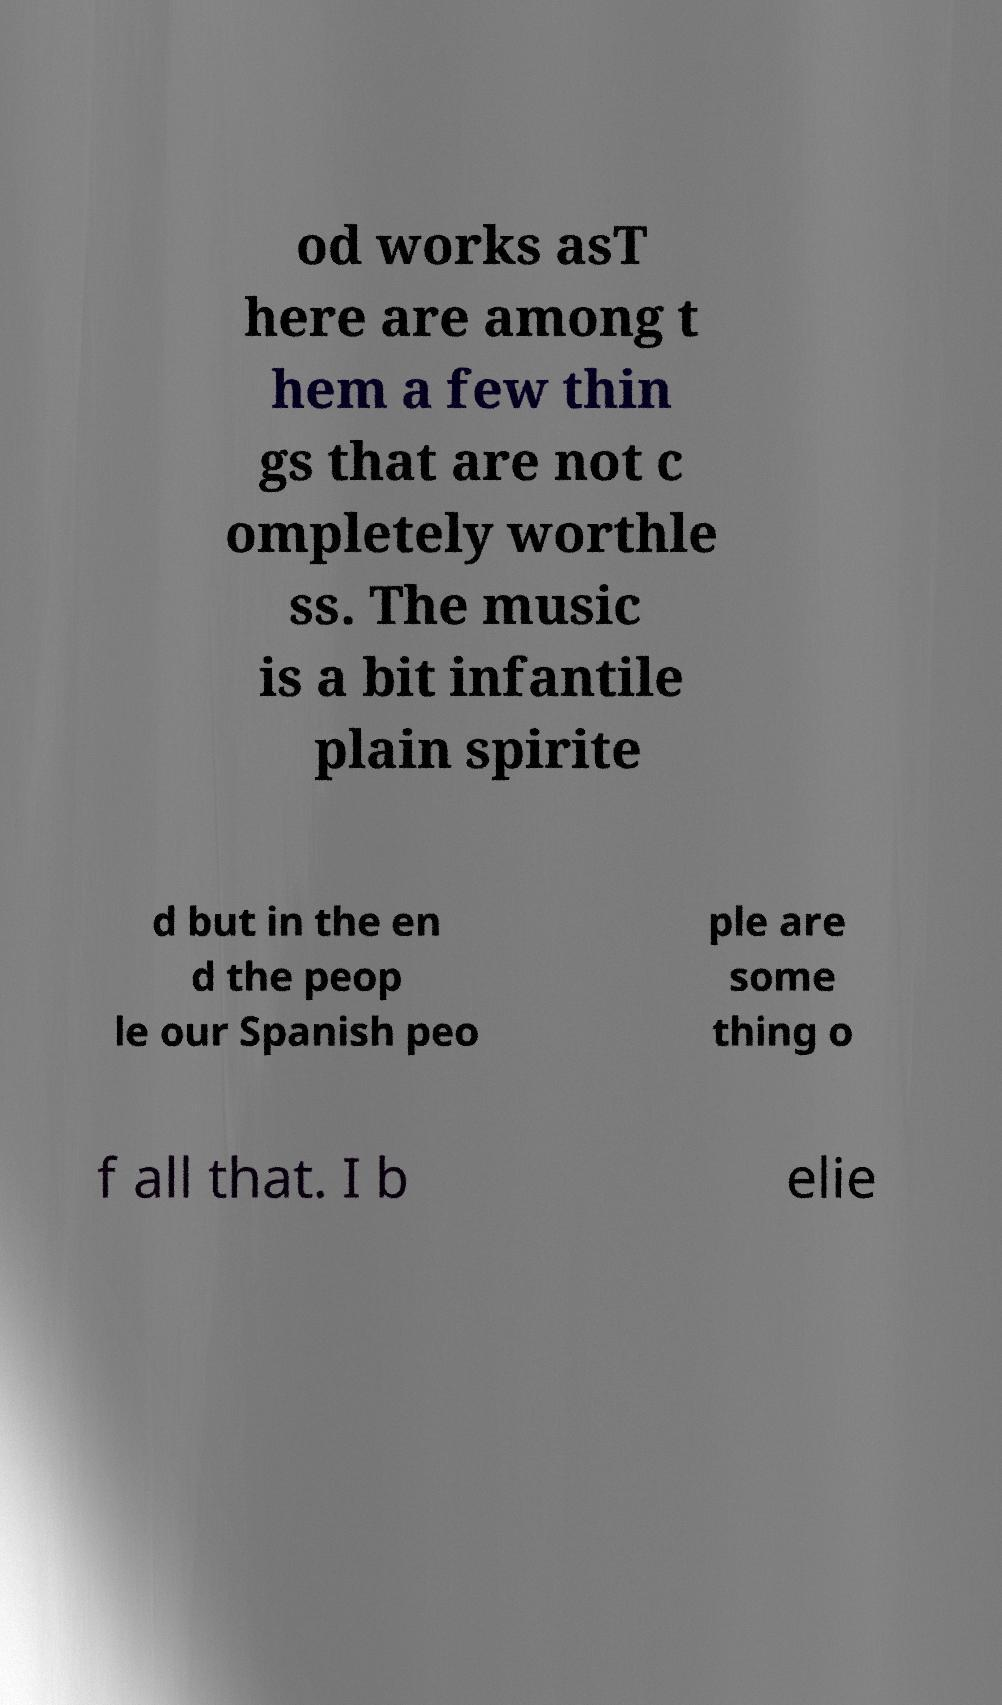I need the written content from this picture converted into text. Can you do that? od works asT here are among t hem a few thin gs that are not c ompletely worthle ss. The music is a bit infantile plain spirite d but in the en d the peop le our Spanish peo ple are some thing o f all that. I b elie 